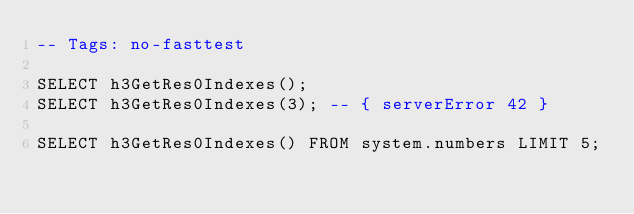Convert code to text. <code><loc_0><loc_0><loc_500><loc_500><_SQL_>-- Tags: no-fasttest

SELECT h3GetRes0Indexes();
SELECT h3GetRes0Indexes(3); -- { serverError 42 }

SELECT h3GetRes0Indexes() FROM system.numbers LIMIT 5;
</code> 